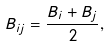<formula> <loc_0><loc_0><loc_500><loc_500>B _ { i j } = \frac { B _ { i } + B _ { j } } { 2 } ,</formula> 